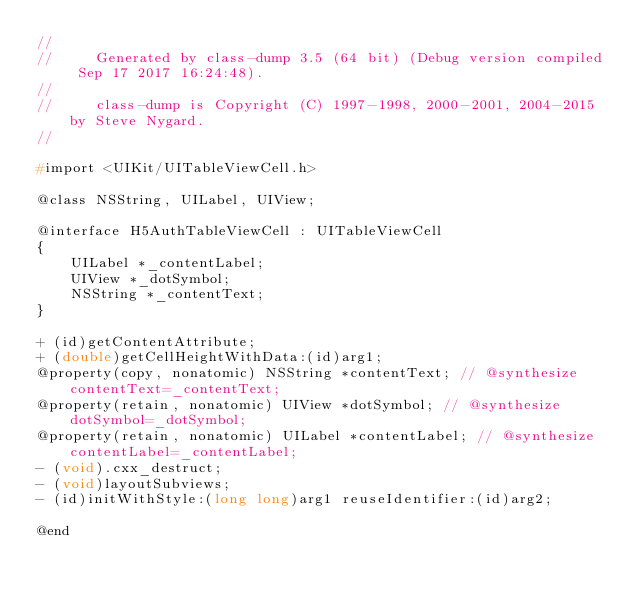<code> <loc_0><loc_0><loc_500><loc_500><_C_>//
//     Generated by class-dump 3.5 (64 bit) (Debug version compiled Sep 17 2017 16:24:48).
//
//     class-dump is Copyright (C) 1997-1998, 2000-2001, 2004-2015 by Steve Nygard.
//

#import <UIKit/UITableViewCell.h>

@class NSString, UILabel, UIView;

@interface H5AuthTableViewCell : UITableViewCell
{
    UILabel *_contentLabel;
    UIView *_dotSymbol;
    NSString *_contentText;
}

+ (id)getContentAttribute;
+ (double)getCellHeightWithData:(id)arg1;
@property(copy, nonatomic) NSString *contentText; // @synthesize contentText=_contentText;
@property(retain, nonatomic) UIView *dotSymbol; // @synthesize dotSymbol=_dotSymbol;
@property(retain, nonatomic) UILabel *contentLabel; // @synthesize contentLabel=_contentLabel;
- (void).cxx_destruct;
- (void)layoutSubviews;
- (id)initWithStyle:(long long)arg1 reuseIdentifier:(id)arg2;

@end

</code> 